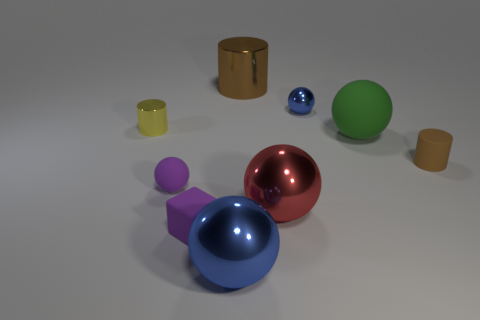Subtract 1 spheres. How many spheres are left? 4 Subtract all cylinders. How many objects are left? 6 Add 2 large red spheres. How many large red spheres exist? 3 Subtract 0 red blocks. How many objects are left? 9 Subtract all gray metallic cylinders. Subtract all tiny balls. How many objects are left? 7 Add 3 big matte things. How many big matte things are left? 4 